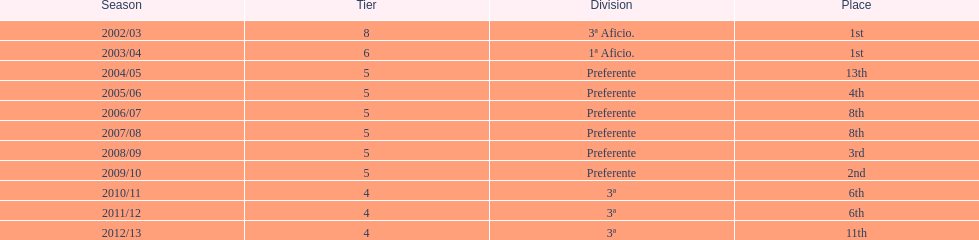How many years has internacional de madrid cf been active in the 3rd division? 3. 